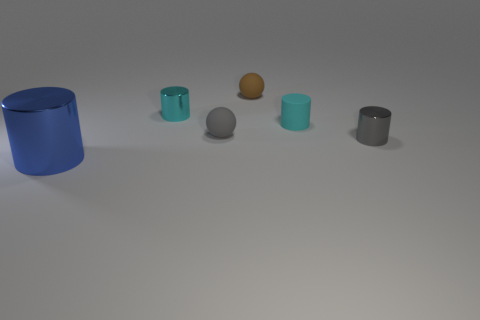Can you describe the objects' arrangement in the image? Certainly! The objects appear to be orderly positioned from the left to the right side of the frame in a staggered linear formation. Starting with a large blue cylinder, followed by smaller objects including a cyan cup, a smaller golden sphere, a medium grey sphere, and ending with two more cups, one transparent blue and one metallic silver. 